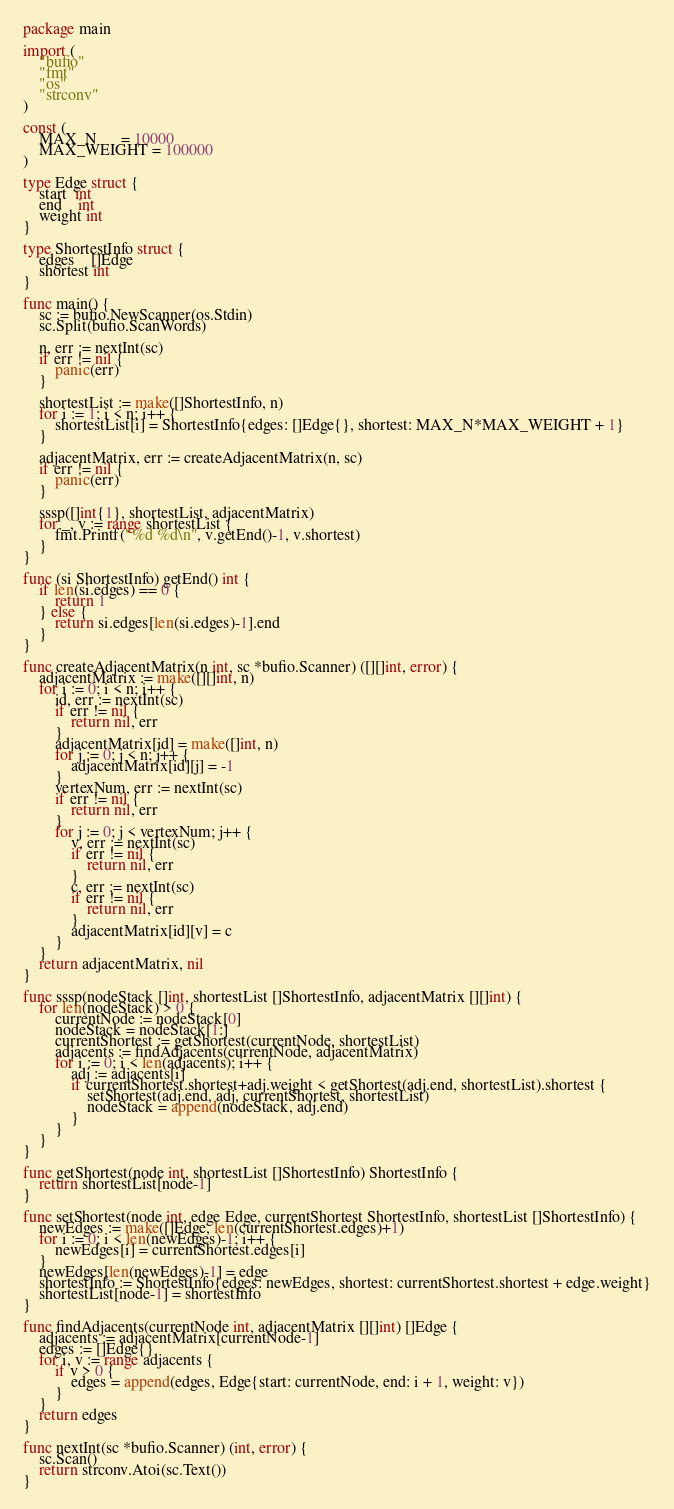<code> <loc_0><loc_0><loc_500><loc_500><_Go_>package main

import (
	"bufio"
	"fmt"
	"os"
	"strconv"
)

const (
	MAX_N      = 10000
	MAX_WEIGHT = 100000
)

type Edge struct {
	start  int
	end    int
	weight int
}

type ShortestInfo struct {
	edges    []Edge
	shortest int
}

func main() {
	sc := bufio.NewScanner(os.Stdin)
	sc.Split(bufio.ScanWords)

	n, err := nextInt(sc)
	if err != nil {
		panic(err)
	}

	shortestList := make([]ShortestInfo, n)
	for i := 1; i < n; i++ {
		shortestList[i] = ShortestInfo{edges: []Edge{}, shortest: MAX_N*MAX_WEIGHT + 1}
	}

	adjacentMatrix, err := createAdjacentMatrix(n, sc)
	if err != nil {
		panic(err)
	}

	sssp([]int{1}, shortestList, adjacentMatrix)
	for _, v := range shortestList {
		fmt.Printf("%d %d\n", v.getEnd()-1, v.shortest)
	}
}

func (si ShortestInfo) getEnd() int {
	if len(si.edges) == 0 {
		return 1
	} else {
		return si.edges[len(si.edges)-1].end
	}
}

func createAdjacentMatrix(n int, sc *bufio.Scanner) ([][]int, error) {
	adjacentMatrix := make([][]int, n)
	for i := 0; i < n; i++ {
		id, err := nextInt(sc)
		if err != nil {
			return nil, err
		}
		adjacentMatrix[id] = make([]int, n)
		for j := 0; j < n; j++ {
			adjacentMatrix[id][j] = -1
		}
		vertexNum, err := nextInt(sc)
		if err != nil {
			return nil, err
		}
		for j := 0; j < vertexNum; j++ {
			v, err := nextInt(sc)
			if err != nil {
				return nil, err
			}
			c, err := nextInt(sc)
			if err != nil {
				return nil, err
			}
			adjacentMatrix[id][v] = c
		}
	}
	return adjacentMatrix, nil
}

func sssp(nodeStack []int, shortestList []ShortestInfo, adjacentMatrix [][]int) {
	for len(nodeStack) > 0 {
		currentNode := nodeStack[0]
		nodeStack = nodeStack[1:]
		currentShortest := getShortest(currentNode, shortestList)
		adjacents := findAdjacents(currentNode, adjacentMatrix)
		for i := 0; i < len(adjacents); i++ {
			adj := adjacents[i]
			if currentShortest.shortest+adj.weight < getShortest(adj.end, shortestList).shortest {
				setShortest(adj.end, adj, currentShortest, shortestList)
				nodeStack = append(nodeStack, adj.end)
			}
		}
	}
}

func getShortest(node int, shortestList []ShortestInfo) ShortestInfo {
	return shortestList[node-1]
}

func setShortest(node int, edge Edge, currentShortest ShortestInfo, shortestList []ShortestInfo) {
	newEdges := make([]Edge, len(currentShortest.edges)+1)
	for i := 0; i < len(newEdges)-1; i++ {
		newEdges[i] = currentShortest.edges[i]
	}
	newEdges[len(newEdges)-1] = edge
	shortestInfo := ShortestInfo{edges: newEdges, shortest: currentShortest.shortest + edge.weight}
	shortestList[node-1] = shortestInfo
}

func findAdjacents(currentNode int, adjacentMatrix [][]int) []Edge {
	adjacents := adjacentMatrix[currentNode-1]
	edges := []Edge{}
	for i, v := range adjacents {
		if v > 0 {
			edges = append(edges, Edge{start: currentNode, end: i + 1, weight: v})
		}
	}
	return edges
}

func nextInt(sc *bufio.Scanner) (int, error) {
	sc.Scan()
	return strconv.Atoi(sc.Text())
}

</code> 